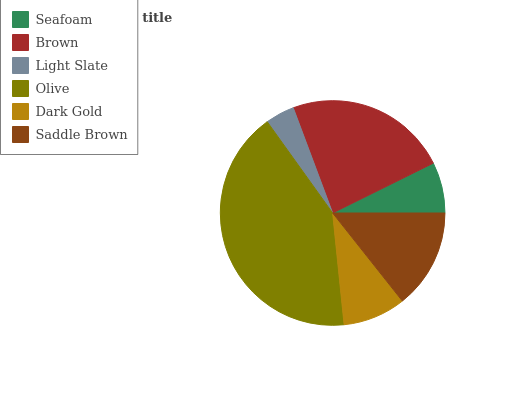Is Light Slate the minimum?
Answer yes or no. Yes. Is Olive the maximum?
Answer yes or no. Yes. Is Brown the minimum?
Answer yes or no. No. Is Brown the maximum?
Answer yes or no. No. Is Brown greater than Seafoam?
Answer yes or no. Yes. Is Seafoam less than Brown?
Answer yes or no. Yes. Is Seafoam greater than Brown?
Answer yes or no. No. Is Brown less than Seafoam?
Answer yes or no. No. Is Saddle Brown the high median?
Answer yes or no. Yes. Is Dark Gold the low median?
Answer yes or no. Yes. Is Brown the high median?
Answer yes or no. No. Is Saddle Brown the low median?
Answer yes or no. No. 